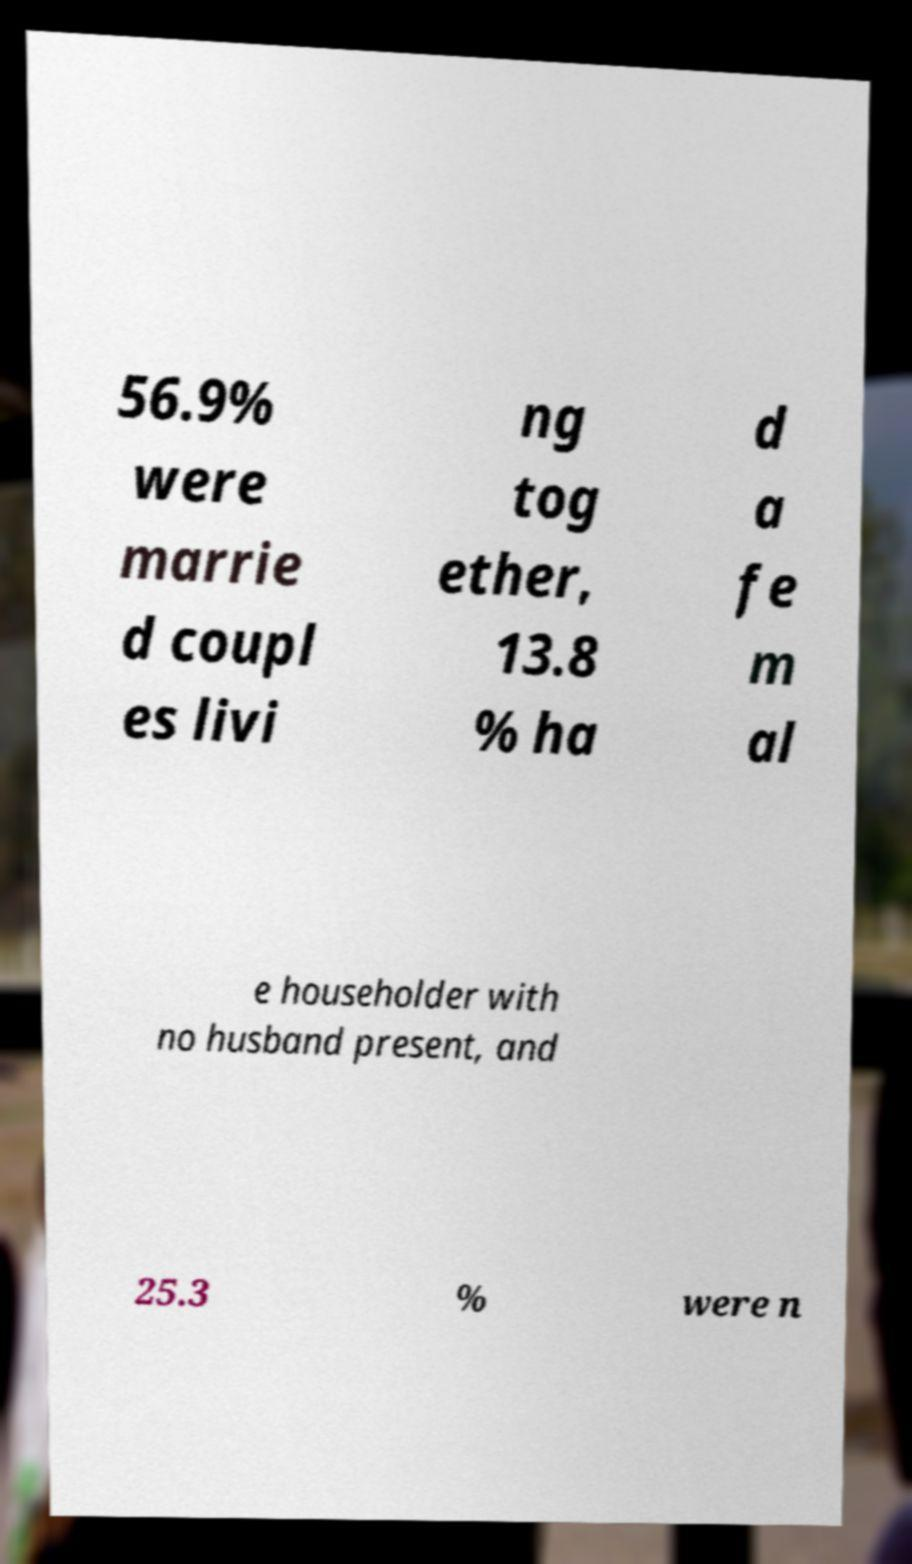Please identify and transcribe the text found in this image. 56.9% were marrie d coupl es livi ng tog ether, 13.8 % ha d a fe m al e householder with no husband present, and 25.3 % were n 